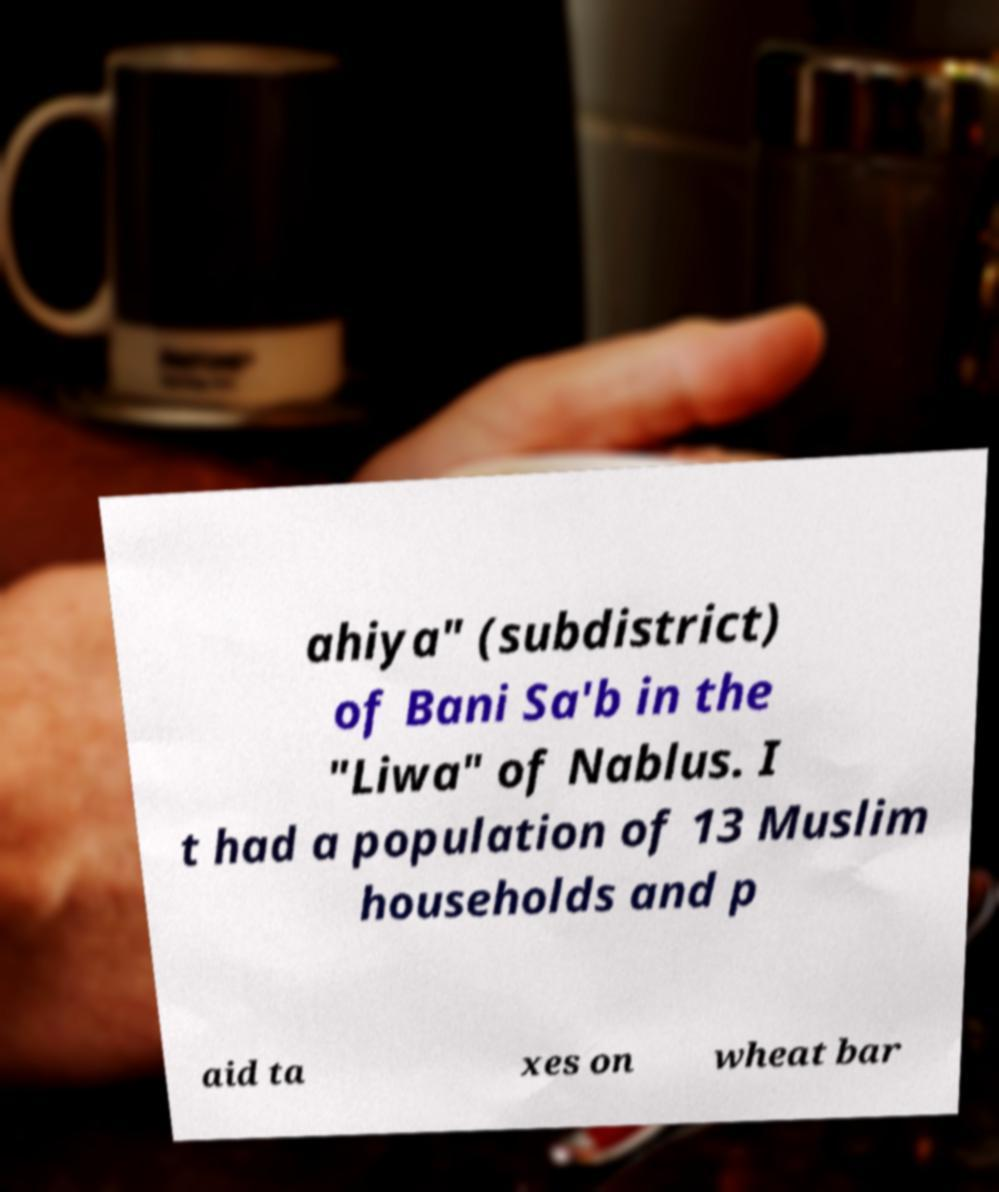There's text embedded in this image that I need extracted. Can you transcribe it verbatim? ahiya" (subdistrict) of Bani Sa'b in the "Liwa" of Nablus. I t had a population of 13 Muslim households and p aid ta xes on wheat bar 